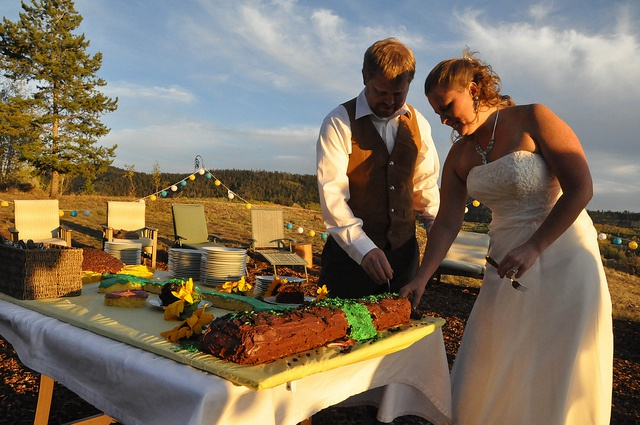Describe the objects in this image and their specific colors. I can see dining table in darkgray, gray, black, brown, and maroon tones, people in darkgray, gray, black, and maroon tones, people in darkgray, black, khaki, maroon, and gray tones, cake in darkgray, black, brown, and maroon tones, and chair in darkgray, tan, black, and olive tones in this image. 